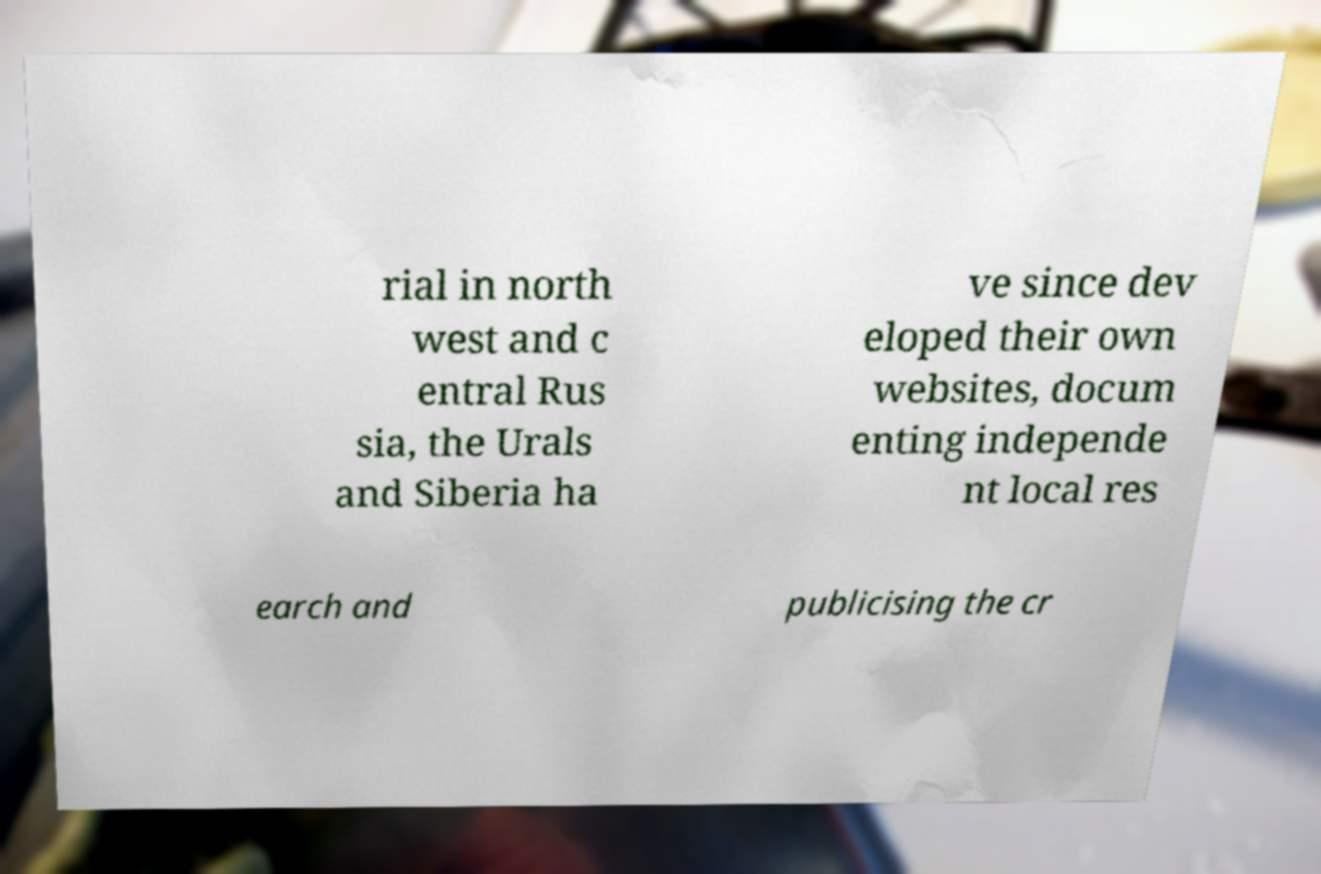I need the written content from this picture converted into text. Can you do that? rial in north west and c entral Rus sia, the Urals and Siberia ha ve since dev eloped their own websites, docum enting independe nt local res earch and publicising the cr 